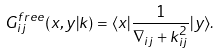Convert formula to latex. <formula><loc_0><loc_0><loc_500><loc_500>G ^ { f r e e } _ { i j } ( x , y | k ) = \langle x | \frac { 1 } { \nabla _ { i j } + k ^ { 2 } _ { i j } } | y \rangle .</formula> 